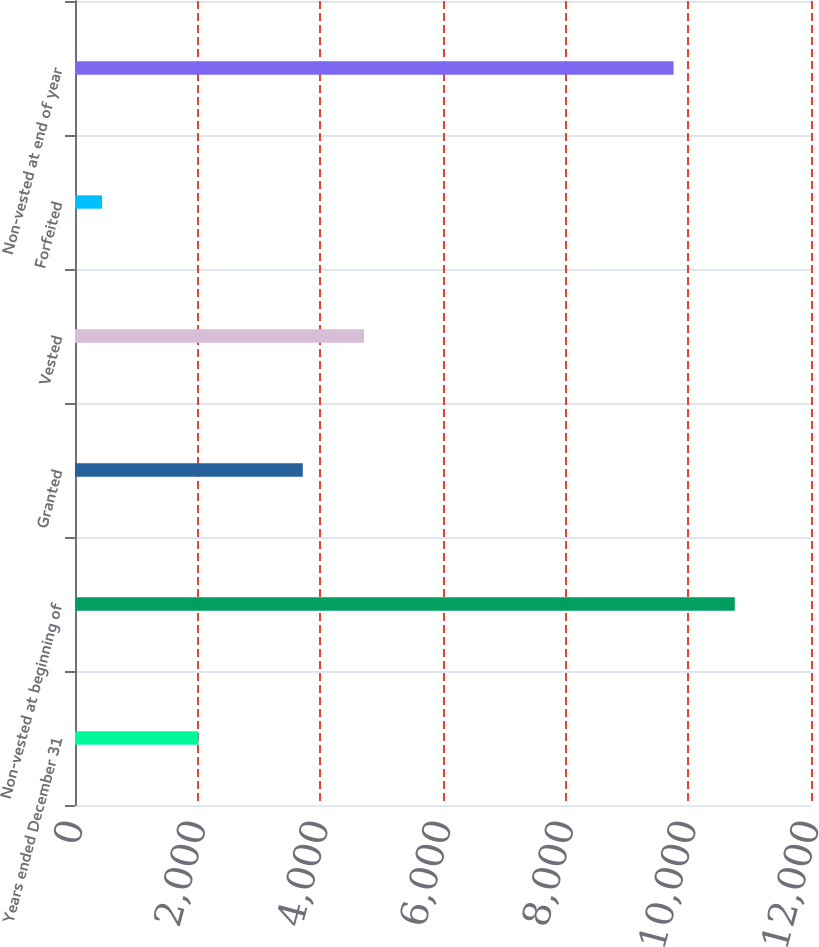Convert chart. <chart><loc_0><loc_0><loc_500><loc_500><bar_chart><fcel>Years ended December 31<fcel>Non-vested at beginning of<fcel>Granted<fcel>Vested<fcel>Forfeited<fcel>Non-vested at end of year<nl><fcel>2013<fcel>10758<fcel>3714<fcel>4713<fcel>442<fcel>9759<nl></chart> 